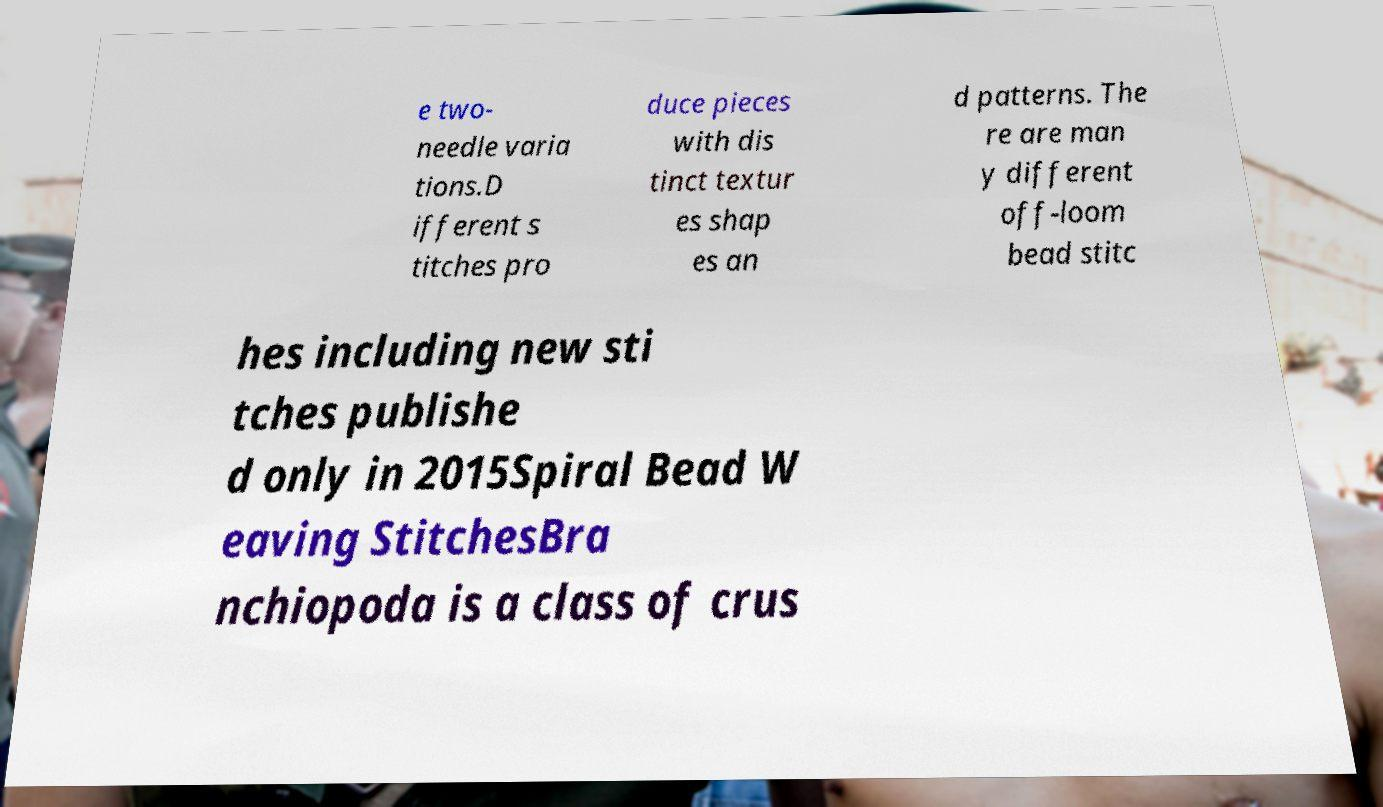Can you read and provide the text displayed in the image?This photo seems to have some interesting text. Can you extract and type it out for me? e two- needle varia tions.D ifferent s titches pro duce pieces with dis tinct textur es shap es an d patterns. The re are man y different off-loom bead stitc hes including new sti tches publishe d only in 2015Spiral Bead W eaving StitchesBra nchiopoda is a class of crus 